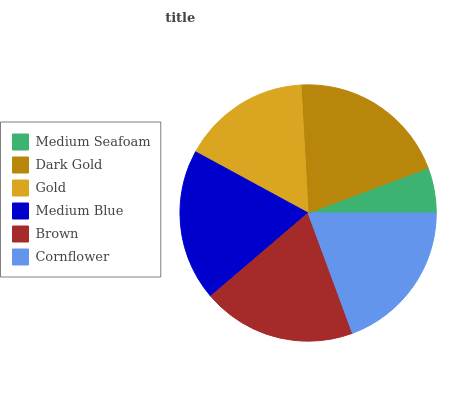Is Medium Seafoam the minimum?
Answer yes or no. Yes. Is Dark Gold the maximum?
Answer yes or no. Yes. Is Gold the minimum?
Answer yes or no. No. Is Gold the maximum?
Answer yes or no. No. Is Dark Gold greater than Gold?
Answer yes or no. Yes. Is Gold less than Dark Gold?
Answer yes or no. Yes. Is Gold greater than Dark Gold?
Answer yes or no. No. Is Dark Gold less than Gold?
Answer yes or no. No. Is Brown the high median?
Answer yes or no. Yes. Is Medium Blue the low median?
Answer yes or no. Yes. Is Gold the high median?
Answer yes or no. No. Is Brown the low median?
Answer yes or no. No. 